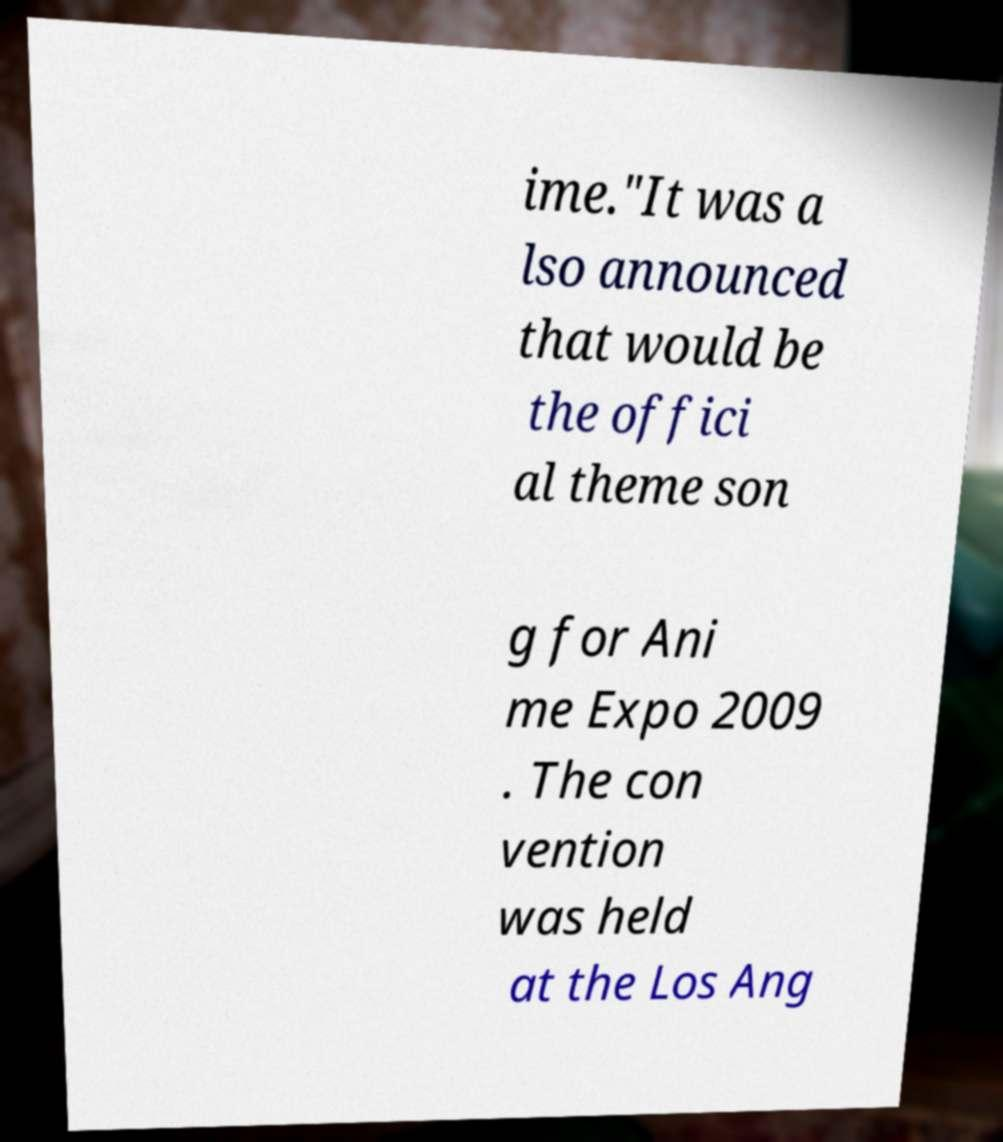Please read and relay the text visible in this image. What does it say? ime."It was a lso announced that would be the offici al theme son g for Ani me Expo 2009 . The con vention was held at the Los Ang 